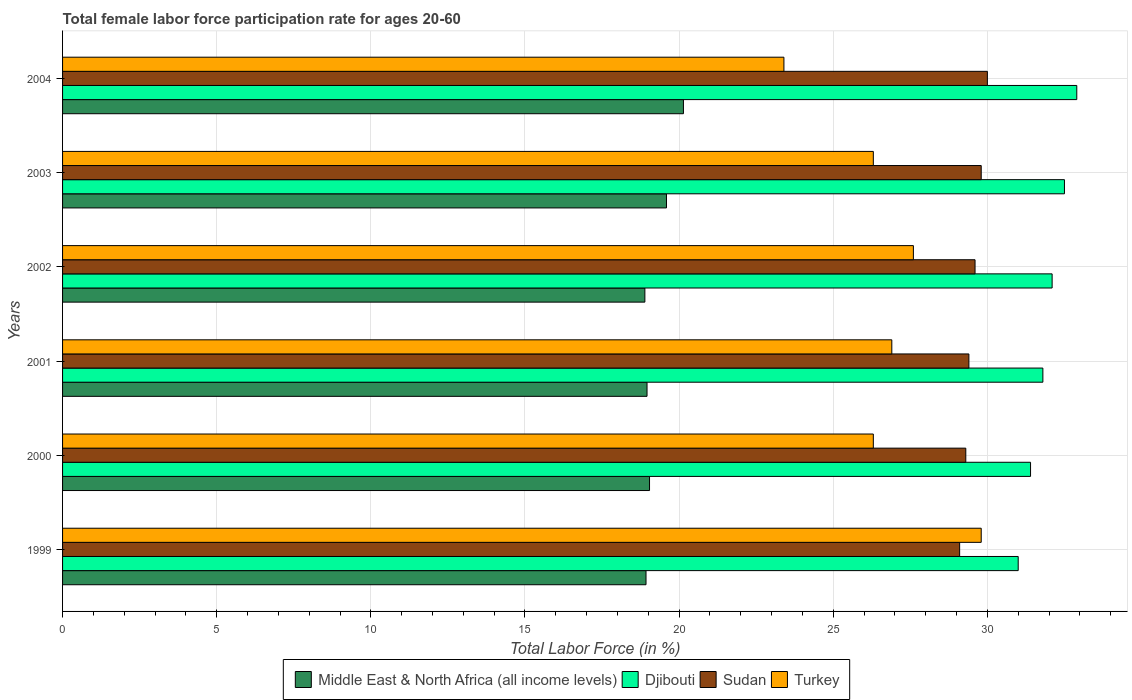How many groups of bars are there?
Offer a terse response. 6. Are the number of bars on each tick of the Y-axis equal?
Your answer should be very brief. Yes. How many bars are there on the 3rd tick from the bottom?
Provide a succinct answer. 4. What is the label of the 2nd group of bars from the top?
Provide a succinct answer. 2003. What is the female labor force participation rate in Turkey in 2001?
Give a very brief answer. 26.9. Across all years, what is the maximum female labor force participation rate in Middle East & North Africa (all income levels)?
Give a very brief answer. 20.14. Across all years, what is the minimum female labor force participation rate in Sudan?
Your response must be concise. 29.1. What is the total female labor force participation rate in Sudan in the graph?
Keep it short and to the point. 177.2. What is the difference between the female labor force participation rate in Djibouti in 2000 and that in 2002?
Provide a short and direct response. -0.7. What is the difference between the female labor force participation rate in Djibouti in 2001 and the female labor force participation rate in Sudan in 2003?
Offer a terse response. 2. What is the average female labor force participation rate in Middle East & North Africa (all income levels) per year?
Provide a succinct answer. 19.26. In the year 2003, what is the difference between the female labor force participation rate in Middle East & North Africa (all income levels) and female labor force participation rate in Sudan?
Keep it short and to the point. -10.21. What is the ratio of the female labor force participation rate in Sudan in 2001 to that in 2004?
Your answer should be very brief. 0.98. Is the female labor force participation rate in Djibouti in 2001 less than that in 2002?
Your answer should be compact. Yes. What is the difference between the highest and the second highest female labor force participation rate in Turkey?
Make the answer very short. 2.2. What is the difference between the highest and the lowest female labor force participation rate in Turkey?
Provide a succinct answer. 6.4. Is it the case that in every year, the sum of the female labor force participation rate in Djibouti and female labor force participation rate in Middle East & North Africa (all income levels) is greater than the sum of female labor force participation rate in Sudan and female labor force participation rate in Turkey?
Give a very brief answer. No. What does the 3rd bar from the top in 1999 represents?
Provide a short and direct response. Djibouti. Is it the case that in every year, the sum of the female labor force participation rate in Middle East & North Africa (all income levels) and female labor force participation rate in Turkey is greater than the female labor force participation rate in Djibouti?
Offer a terse response. Yes. How many bars are there?
Keep it short and to the point. 24. How many years are there in the graph?
Provide a short and direct response. 6. Does the graph contain grids?
Give a very brief answer. Yes. How many legend labels are there?
Keep it short and to the point. 4. How are the legend labels stacked?
Offer a terse response. Horizontal. What is the title of the graph?
Offer a very short reply. Total female labor force participation rate for ages 20-60. What is the Total Labor Force (in %) of Middle East & North Africa (all income levels) in 1999?
Your answer should be compact. 18.93. What is the Total Labor Force (in %) of Djibouti in 1999?
Offer a terse response. 31. What is the Total Labor Force (in %) of Sudan in 1999?
Your answer should be very brief. 29.1. What is the Total Labor Force (in %) of Turkey in 1999?
Your answer should be compact. 29.8. What is the Total Labor Force (in %) in Middle East & North Africa (all income levels) in 2000?
Provide a short and direct response. 19.04. What is the Total Labor Force (in %) of Djibouti in 2000?
Provide a succinct answer. 31.4. What is the Total Labor Force (in %) in Sudan in 2000?
Make the answer very short. 29.3. What is the Total Labor Force (in %) in Turkey in 2000?
Provide a short and direct response. 26.3. What is the Total Labor Force (in %) in Middle East & North Africa (all income levels) in 2001?
Your answer should be very brief. 18.96. What is the Total Labor Force (in %) in Djibouti in 2001?
Make the answer very short. 31.8. What is the Total Labor Force (in %) in Sudan in 2001?
Ensure brevity in your answer.  29.4. What is the Total Labor Force (in %) in Turkey in 2001?
Give a very brief answer. 26.9. What is the Total Labor Force (in %) of Middle East & North Africa (all income levels) in 2002?
Provide a succinct answer. 18.89. What is the Total Labor Force (in %) in Djibouti in 2002?
Provide a succinct answer. 32.1. What is the Total Labor Force (in %) in Sudan in 2002?
Keep it short and to the point. 29.6. What is the Total Labor Force (in %) of Turkey in 2002?
Keep it short and to the point. 27.6. What is the Total Labor Force (in %) of Middle East & North Africa (all income levels) in 2003?
Ensure brevity in your answer.  19.59. What is the Total Labor Force (in %) of Djibouti in 2003?
Keep it short and to the point. 32.5. What is the Total Labor Force (in %) of Sudan in 2003?
Make the answer very short. 29.8. What is the Total Labor Force (in %) of Turkey in 2003?
Make the answer very short. 26.3. What is the Total Labor Force (in %) of Middle East & North Africa (all income levels) in 2004?
Provide a short and direct response. 20.14. What is the Total Labor Force (in %) of Djibouti in 2004?
Provide a short and direct response. 32.9. What is the Total Labor Force (in %) in Turkey in 2004?
Offer a terse response. 23.4. Across all years, what is the maximum Total Labor Force (in %) of Middle East & North Africa (all income levels)?
Your answer should be very brief. 20.14. Across all years, what is the maximum Total Labor Force (in %) in Djibouti?
Your answer should be compact. 32.9. Across all years, what is the maximum Total Labor Force (in %) of Sudan?
Your answer should be compact. 30. Across all years, what is the maximum Total Labor Force (in %) of Turkey?
Provide a short and direct response. 29.8. Across all years, what is the minimum Total Labor Force (in %) of Middle East & North Africa (all income levels)?
Offer a very short reply. 18.89. Across all years, what is the minimum Total Labor Force (in %) of Djibouti?
Keep it short and to the point. 31. Across all years, what is the minimum Total Labor Force (in %) in Sudan?
Provide a short and direct response. 29.1. Across all years, what is the minimum Total Labor Force (in %) in Turkey?
Provide a short and direct response. 23.4. What is the total Total Labor Force (in %) of Middle East & North Africa (all income levels) in the graph?
Provide a short and direct response. 115.55. What is the total Total Labor Force (in %) in Djibouti in the graph?
Your answer should be very brief. 191.7. What is the total Total Labor Force (in %) of Sudan in the graph?
Ensure brevity in your answer.  177.2. What is the total Total Labor Force (in %) of Turkey in the graph?
Your answer should be very brief. 160.3. What is the difference between the Total Labor Force (in %) in Middle East & North Africa (all income levels) in 1999 and that in 2000?
Offer a very short reply. -0.11. What is the difference between the Total Labor Force (in %) of Djibouti in 1999 and that in 2000?
Keep it short and to the point. -0.4. What is the difference between the Total Labor Force (in %) in Middle East & North Africa (all income levels) in 1999 and that in 2001?
Make the answer very short. -0.03. What is the difference between the Total Labor Force (in %) of Turkey in 1999 and that in 2001?
Keep it short and to the point. 2.9. What is the difference between the Total Labor Force (in %) in Middle East & North Africa (all income levels) in 1999 and that in 2002?
Keep it short and to the point. 0.04. What is the difference between the Total Labor Force (in %) in Djibouti in 1999 and that in 2002?
Offer a very short reply. -1.1. What is the difference between the Total Labor Force (in %) in Middle East & North Africa (all income levels) in 1999 and that in 2003?
Ensure brevity in your answer.  -0.66. What is the difference between the Total Labor Force (in %) in Djibouti in 1999 and that in 2003?
Offer a terse response. -1.5. What is the difference between the Total Labor Force (in %) of Turkey in 1999 and that in 2003?
Your answer should be compact. 3.5. What is the difference between the Total Labor Force (in %) in Middle East & North Africa (all income levels) in 1999 and that in 2004?
Ensure brevity in your answer.  -1.21. What is the difference between the Total Labor Force (in %) in Djibouti in 1999 and that in 2004?
Offer a terse response. -1.9. What is the difference between the Total Labor Force (in %) of Turkey in 1999 and that in 2004?
Provide a short and direct response. 6.4. What is the difference between the Total Labor Force (in %) in Middle East & North Africa (all income levels) in 2000 and that in 2001?
Give a very brief answer. 0.08. What is the difference between the Total Labor Force (in %) of Turkey in 2000 and that in 2001?
Your response must be concise. -0.6. What is the difference between the Total Labor Force (in %) of Middle East & North Africa (all income levels) in 2000 and that in 2002?
Provide a succinct answer. 0.15. What is the difference between the Total Labor Force (in %) of Djibouti in 2000 and that in 2002?
Offer a terse response. -0.7. What is the difference between the Total Labor Force (in %) of Sudan in 2000 and that in 2002?
Give a very brief answer. -0.3. What is the difference between the Total Labor Force (in %) of Turkey in 2000 and that in 2002?
Make the answer very short. -1.3. What is the difference between the Total Labor Force (in %) of Middle East & North Africa (all income levels) in 2000 and that in 2003?
Provide a short and direct response. -0.55. What is the difference between the Total Labor Force (in %) in Djibouti in 2000 and that in 2003?
Ensure brevity in your answer.  -1.1. What is the difference between the Total Labor Force (in %) of Sudan in 2000 and that in 2003?
Provide a succinct answer. -0.5. What is the difference between the Total Labor Force (in %) of Turkey in 2000 and that in 2003?
Give a very brief answer. 0. What is the difference between the Total Labor Force (in %) in Middle East & North Africa (all income levels) in 2000 and that in 2004?
Your answer should be very brief. -1.1. What is the difference between the Total Labor Force (in %) in Middle East & North Africa (all income levels) in 2001 and that in 2002?
Ensure brevity in your answer.  0.07. What is the difference between the Total Labor Force (in %) in Djibouti in 2001 and that in 2002?
Make the answer very short. -0.3. What is the difference between the Total Labor Force (in %) in Middle East & North Africa (all income levels) in 2001 and that in 2003?
Offer a terse response. -0.63. What is the difference between the Total Labor Force (in %) in Turkey in 2001 and that in 2003?
Make the answer very short. 0.6. What is the difference between the Total Labor Force (in %) in Middle East & North Africa (all income levels) in 2001 and that in 2004?
Make the answer very short. -1.18. What is the difference between the Total Labor Force (in %) in Djibouti in 2001 and that in 2004?
Provide a short and direct response. -1.1. What is the difference between the Total Labor Force (in %) of Sudan in 2001 and that in 2004?
Your answer should be very brief. -0.6. What is the difference between the Total Labor Force (in %) of Turkey in 2001 and that in 2004?
Offer a terse response. 3.5. What is the difference between the Total Labor Force (in %) in Middle East & North Africa (all income levels) in 2002 and that in 2003?
Provide a short and direct response. -0.7. What is the difference between the Total Labor Force (in %) in Sudan in 2002 and that in 2003?
Your response must be concise. -0.2. What is the difference between the Total Labor Force (in %) of Turkey in 2002 and that in 2003?
Provide a short and direct response. 1.3. What is the difference between the Total Labor Force (in %) in Middle East & North Africa (all income levels) in 2002 and that in 2004?
Offer a very short reply. -1.25. What is the difference between the Total Labor Force (in %) in Middle East & North Africa (all income levels) in 2003 and that in 2004?
Your response must be concise. -0.55. What is the difference between the Total Labor Force (in %) in Djibouti in 2003 and that in 2004?
Give a very brief answer. -0.4. What is the difference between the Total Labor Force (in %) in Sudan in 2003 and that in 2004?
Provide a short and direct response. -0.2. What is the difference between the Total Labor Force (in %) in Turkey in 2003 and that in 2004?
Offer a terse response. 2.9. What is the difference between the Total Labor Force (in %) in Middle East & North Africa (all income levels) in 1999 and the Total Labor Force (in %) in Djibouti in 2000?
Offer a very short reply. -12.47. What is the difference between the Total Labor Force (in %) of Middle East & North Africa (all income levels) in 1999 and the Total Labor Force (in %) of Sudan in 2000?
Your response must be concise. -10.37. What is the difference between the Total Labor Force (in %) in Middle East & North Africa (all income levels) in 1999 and the Total Labor Force (in %) in Turkey in 2000?
Your answer should be very brief. -7.37. What is the difference between the Total Labor Force (in %) in Djibouti in 1999 and the Total Labor Force (in %) in Turkey in 2000?
Your response must be concise. 4.7. What is the difference between the Total Labor Force (in %) of Sudan in 1999 and the Total Labor Force (in %) of Turkey in 2000?
Keep it short and to the point. 2.8. What is the difference between the Total Labor Force (in %) in Middle East & North Africa (all income levels) in 1999 and the Total Labor Force (in %) in Djibouti in 2001?
Ensure brevity in your answer.  -12.87. What is the difference between the Total Labor Force (in %) in Middle East & North Africa (all income levels) in 1999 and the Total Labor Force (in %) in Sudan in 2001?
Provide a short and direct response. -10.47. What is the difference between the Total Labor Force (in %) in Middle East & North Africa (all income levels) in 1999 and the Total Labor Force (in %) in Turkey in 2001?
Make the answer very short. -7.97. What is the difference between the Total Labor Force (in %) in Djibouti in 1999 and the Total Labor Force (in %) in Sudan in 2001?
Your answer should be compact. 1.6. What is the difference between the Total Labor Force (in %) in Djibouti in 1999 and the Total Labor Force (in %) in Turkey in 2001?
Offer a terse response. 4.1. What is the difference between the Total Labor Force (in %) in Sudan in 1999 and the Total Labor Force (in %) in Turkey in 2001?
Offer a very short reply. 2.2. What is the difference between the Total Labor Force (in %) in Middle East & North Africa (all income levels) in 1999 and the Total Labor Force (in %) in Djibouti in 2002?
Keep it short and to the point. -13.17. What is the difference between the Total Labor Force (in %) of Middle East & North Africa (all income levels) in 1999 and the Total Labor Force (in %) of Sudan in 2002?
Provide a short and direct response. -10.67. What is the difference between the Total Labor Force (in %) of Middle East & North Africa (all income levels) in 1999 and the Total Labor Force (in %) of Turkey in 2002?
Make the answer very short. -8.67. What is the difference between the Total Labor Force (in %) of Djibouti in 1999 and the Total Labor Force (in %) of Sudan in 2002?
Keep it short and to the point. 1.4. What is the difference between the Total Labor Force (in %) of Djibouti in 1999 and the Total Labor Force (in %) of Turkey in 2002?
Provide a succinct answer. 3.4. What is the difference between the Total Labor Force (in %) of Middle East & North Africa (all income levels) in 1999 and the Total Labor Force (in %) of Djibouti in 2003?
Offer a very short reply. -13.57. What is the difference between the Total Labor Force (in %) in Middle East & North Africa (all income levels) in 1999 and the Total Labor Force (in %) in Sudan in 2003?
Provide a short and direct response. -10.87. What is the difference between the Total Labor Force (in %) of Middle East & North Africa (all income levels) in 1999 and the Total Labor Force (in %) of Turkey in 2003?
Give a very brief answer. -7.37. What is the difference between the Total Labor Force (in %) of Djibouti in 1999 and the Total Labor Force (in %) of Turkey in 2003?
Provide a succinct answer. 4.7. What is the difference between the Total Labor Force (in %) in Sudan in 1999 and the Total Labor Force (in %) in Turkey in 2003?
Ensure brevity in your answer.  2.8. What is the difference between the Total Labor Force (in %) of Middle East & North Africa (all income levels) in 1999 and the Total Labor Force (in %) of Djibouti in 2004?
Offer a terse response. -13.97. What is the difference between the Total Labor Force (in %) of Middle East & North Africa (all income levels) in 1999 and the Total Labor Force (in %) of Sudan in 2004?
Make the answer very short. -11.07. What is the difference between the Total Labor Force (in %) of Middle East & North Africa (all income levels) in 1999 and the Total Labor Force (in %) of Turkey in 2004?
Provide a succinct answer. -4.47. What is the difference between the Total Labor Force (in %) in Djibouti in 1999 and the Total Labor Force (in %) in Turkey in 2004?
Provide a short and direct response. 7.6. What is the difference between the Total Labor Force (in %) of Middle East & North Africa (all income levels) in 2000 and the Total Labor Force (in %) of Djibouti in 2001?
Your answer should be compact. -12.76. What is the difference between the Total Labor Force (in %) in Middle East & North Africa (all income levels) in 2000 and the Total Labor Force (in %) in Sudan in 2001?
Provide a short and direct response. -10.36. What is the difference between the Total Labor Force (in %) in Middle East & North Africa (all income levels) in 2000 and the Total Labor Force (in %) in Turkey in 2001?
Ensure brevity in your answer.  -7.86. What is the difference between the Total Labor Force (in %) of Djibouti in 2000 and the Total Labor Force (in %) of Sudan in 2001?
Keep it short and to the point. 2. What is the difference between the Total Labor Force (in %) of Middle East & North Africa (all income levels) in 2000 and the Total Labor Force (in %) of Djibouti in 2002?
Provide a short and direct response. -13.06. What is the difference between the Total Labor Force (in %) of Middle East & North Africa (all income levels) in 2000 and the Total Labor Force (in %) of Sudan in 2002?
Offer a very short reply. -10.56. What is the difference between the Total Labor Force (in %) of Middle East & North Africa (all income levels) in 2000 and the Total Labor Force (in %) of Turkey in 2002?
Provide a succinct answer. -8.56. What is the difference between the Total Labor Force (in %) of Djibouti in 2000 and the Total Labor Force (in %) of Turkey in 2002?
Your answer should be compact. 3.8. What is the difference between the Total Labor Force (in %) in Sudan in 2000 and the Total Labor Force (in %) in Turkey in 2002?
Provide a short and direct response. 1.7. What is the difference between the Total Labor Force (in %) in Middle East & North Africa (all income levels) in 2000 and the Total Labor Force (in %) in Djibouti in 2003?
Give a very brief answer. -13.46. What is the difference between the Total Labor Force (in %) of Middle East & North Africa (all income levels) in 2000 and the Total Labor Force (in %) of Sudan in 2003?
Provide a short and direct response. -10.76. What is the difference between the Total Labor Force (in %) of Middle East & North Africa (all income levels) in 2000 and the Total Labor Force (in %) of Turkey in 2003?
Your answer should be very brief. -7.26. What is the difference between the Total Labor Force (in %) of Djibouti in 2000 and the Total Labor Force (in %) of Sudan in 2003?
Your answer should be compact. 1.6. What is the difference between the Total Labor Force (in %) in Djibouti in 2000 and the Total Labor Force (in %) in Turkey in 2003?
Provide a short and direct response. 5.1. What is the difference between the Total Labor Force (in %) in Middle East & North Africa (all income levels) in 2000 and the Total Labor Force (in %) in Djibouti in 2004?
Keep it short and to the point. -13.86. What is the difference between the Total Labor Force (in %) of Middle East & North Africa (all income levels) in 2000 and the Total Labor Force (in %) of Sudan in 2004?
Offer a terse response. -10.96. What is the difference between the Total Labor Force (in %) in Middle East & North Africa (all income levels) in 2000 and the Total Labor Force (in %) in Turkey in 2004?
Provide a succinct answer. -4.36. What is the difference between the Total Labor Force (in %) of Djibouti in 2000 and the Total Labor Force (in %) of Sudan in 2004?
Give a very brief answer. 1.4. What is the difference between the Total Labor Force (in %) of Djibouti in 2000 and the Total Labor Force (in %) of Turkey in 2004?
Ensure brevity in your answer.  8. What is the difference between the Total Labor Force (in %) in Middle East & North Africa (all income levels) in 2001 and the Total Labor Force (in %) in Djibouti in 2002?
Provide a short and direct response. -13.14. What is the difference between the Total Labor Force (in %) of Middle East & North Africa (all income levels) in 2001 and the Total Labor Force (in %) of Sudan in 2002?
Your answer should be compact. -10.64. What is the difference between the Total Labor Force (in %) of Middle East & North Africa (all income levels) in 2001 and the Total Labor Force (in %) of Turkey in 2002?
Ensure brevity in your answer.  -8.64. What is the difference between the Total Labor Force (in %) of Middle East & North Africa (all income levels) in 2001 and the Total Labor Force (in %) of Djibouti in 2003?
Offer a very short reply. -13.54. What is the difference between the Total Labor Force (in %) in Middle East & North Africa (all income levels) in 2001 and the Total Labor Force (in %) in Sudan in 2003?
Offer a very short reply. -10.84. What is the difference between the Total Labor Force (in %) of Middle East & North Africa (all income levels) in 2001 and the Total Labor Force (in %) of Turkey in 2003?
Offer a terse response. -7.34. What is the difference between the Total Labor Force (in %) in Djibouti in 2001 and the Total Labor Force (in %) in Sudan in 2003?
Provide a short and direct response. 2. What is the difference between the Total Labor Force (in %) of Djibouti in 2001 and the Total Labor Force (in %) of Turkey in 2003?
Provide a succinct answer. 5.5. What is the difference between the Total Labor Force (in %) in Sudan in 2001 and the Total Labor Force (in %) in Turkey in 2003?
Offer a very short reply. 3.1. What is the difference between the Total Labor Force (in %) in Middle East & North Africa (all income levels) in 2001 and the Total Labor Force (in %) in Djibouti in 2004?
Your response must be concise. -13.94. What is the difference between the Total Labor Force (in %) in Middle East & North Africa (all income levels) in 2001 and the Total Labor Force (in %) in Sudan in 2004?
Offer a very short reply. -11.04. What is the difference between the Total Labor Force (in %) in Middle East & North Africa (all income levels) in 2001 and the Total Labor Force (in %) in Turkey in 2004?
Ensure brevity in your answer.  -4.44. What is the difference between the Total Labor Force (in %) of Djibouti in 2001 and the Total Labor Force (in %) of Sudan in 2004?
Ensure brevity in your answer.  1.8. What is the difference between the Total Labor Force (in %) in Djibouti in 2001 and the Total Labor Force (in %) in Turkey in 2004?
Offer a terse response. 8.4. What is the difference between the Total Labor Force (in %) of Middle East & North Africa (all income levels) in 2002 and the Total Labor Force (in %) of Djibouti in 2003?
Make the answer very short. -13.61. What is the difference between the Total Labor Force (in %) of Middle East & North Africa (all income levels) in 2002 and the Total Labor Force (in %) of Sudan in 2003?
Your response must be concise. -10.91. What is the difference between the Total Labor Force (in %) of Middle East & North Africa (all income levels) in 2002 and the Total Labor Force (in %) of Turkey in 2003?
Offer a terse response. -7.41. What is the difference between the Total Labor Force (in %) of Middle East & North Africa (all income levels) in 2002 and the Total Labor Force (in %) of Djibouti in 2004?
Keep it short and to the point. -14.01. What is the difference between the Total Labor Force (in %) in Middle East & North Africa (all income levels) in 2002 and the Total Labor Force (in %) in Sudan in 2004?
Your answer should be very brief. -11.11. What is the difference between the Total Labor Force (in %) in Middle East & North Africa (all income levels) in 2002 and the Total Labor Force (in %) in Turkey in 2004?
Ensure brevity in your answer.  -4.51. What is the difference between the Total Labor Force (in %) in Djibouti in 2002 and the Total Labor Force (in %) in Sudan in 2004?
Your answer should be compact. 2.1. What is the difference between the Total Labor Force (in %) of Middle East & North Africa (all income levels) in 2003 and the Total Labor Force (in %) of Djibouti in 2004?
Ensure brevity in your answer.  -13.31. What is the difference between the Total Labor Force (in %) of Middle East & North Africa (all income levels) in 2003 and the Total Labor Force (in %) of Sudan in 2004?
Your answer should be very brief. -10.41. What is the difference between the Total Labor Force (in %) of Middle East & North Africa (all income levels) in 2003 and the Total Labor Force (in %) of Turkey in 2004?
Your response must be concise. -3.81. What is the difference between the Total Labor Force (in %) in Djibouti in 2003 and the Total Labor Force (in %) in Sudan in 2004?
Provide a succinct answer. 2.5. What is the difference between the Total Labor Force (in %) of Djibouti in 2003 and the Total Labor Force (in %) of Turkey in 2004?
Your response must be concise. 9.1. What is the average Total Labor Force (in %) of Middle East & North Africa (all income levels) per year?
Provide a succinct answer. 19.26. What is the average Total Labor Force (in %) of Djibouti per year?
Offer a terse response. 31.95. What is the average Total Labor Force (in %) of Sudan per year?
Offer a very short reply. 29.53. What is the average Total Labor Force (in %) in Turkey per year?
Your answer should be very brief. 26.72. In the year 1999, what is the difference between the Total Labor Force (in %) of Middle East & North Africa (all income levels) and Total Labor Force (in %) of Djibouti?
Keep it short and to the point. -12.07. In the year 1999, what is the difference between the Total Labor Force (in %) in Middle East & North Africa (all income levels) and Total Labor Force (in %) in Sudan?
Your response must be concise. -10.17. In the year 1999, what is the difference between the Total Labor Force (in %) in Middle East & North Africa (all income levels) and Total Labor Force (in %) in Turkey?
Ensure brevity in your answer.  -10.87. In the year 1999, what is the difference between the Total Labor Force (in %) in Djibouti and Total Labor Force (in %) in Turkey?
Your answer should be compact. 1.2. In the year 2000, what is the difference between the Total Labor Force (in %) in Middle East & North Africa (all income levels) and Total Labor Force (in %) in Djibouti?
Make the answer very short. -12.36. In the year 2000, what is the difference between the Total Labor Force (in %) of Middle East & North Africa (all income levels) and Total Labor Force (in %) of Sudan?
Offer a very short reply. -10.26. In the year 2000, what is the difference between the Total Labor Force (in %) of Middle East & North Africa (all income levels) and Total Labor Force (in %) of Turkey?
Offer a terse response. -7.26. In the year 2000, what is the difference between the Total Labor Force (in %) in Djibouti and Total Labor Force (in %) in Turkey?
Keep it short and to the point. 5.1. In the year 2001, what is the difference between the Total Labor Force (in %) of Middle East & North Africa (all income levels) and Total Labor Force (in %) of Djibouti?
Your response must be concise. -12.84. In the year 2001, what is the difference between the Total Labor Force (in %) in Middle East & North Africa (all income levels) and Total Labor Force (in %) in Sudan?
Offer a terse response. -10.44. In the year 2001, what is the difference between the Total Labor Force (in %) of Middle East & North Africa (all income levels) and Total Labor Force (in %) of Turkey?
Give a very brief answer. -7.94. In the year 2001, what is the difference between the Total Labor Force (in %) of Djibouti and Total Labor Force (in %) of Sudan?
Make the answer very short. 2.4. In the year 2002, what is the difference between the Total Labor Force (in %) in Middle East & North Africa (all income levels) and Total Labor Force (in %) in Djibouti?
Your response must be concise. -13.21. In the year 2002, what is the difference between the Total Labor Force (in %) of Middle East & North Africa (all income levels) and Total Labor Force (in %) of Sudan?
Your answer should be compact. -10.71. In the year 2002, what is the difference between the Total Labor Force (in %) in Middle East & North Africa (all income levels) and Total Labor Force (in %) in Turkey?
Provide a succinct answer. -8.71. In the year 2002, what is the difference between the Total Labor Force (in %) in Djibouti and Total Labor Force (in %) in Turkey?
Your response must be concise. 4.5. In the year 2003, what is the difference between the Total Labor Force (in %) of Middle East & North Africa (all income levels) and Total Labor Force (in %) of Djibouti?
Your answer should be compact. -12.91. In the year 2003, what is the difference between the Total Labor Force (in %) of Middle East & North Africa (all income levels) and Total Labor Force (in %) of Sudan?
Your answer should be compact. -10.21. In the year 2003, what is the difference between the Total Labor Force (in %) in Middle East & North Africa (all income levels) and Total Labor Force (in %) in Turkey?
Offer a terse response. -6.71. In the year 2003, what is the difference between the Total Labor Force (in %) in Sudan and Total Labor Force (in %) in Turkey?
Keep it short and to the point. 3.5. In the year 2004, what is the difference between the Total Labor Force (in %) in Middle East & North Africa (all income levels) and Total Labor Force (in %) in Djibouti?
Provide a short and direct response. -12.76. In the year 2004, what is the difference between the Total Labor Force (in %) of Middle East & North Africa (all income levels) and Total Labor Force (in %) of Sudan?
Your answer should be compact. -9.86. In the year 2004, what is the difference between the Total Labor Force (in %) of Middle East & North Africa (all income levels) and Total Labor Force (in %) of Turkey?
Give a very brief answer. -3.26. In the year 2004, what is the difference between the Total Labor Force (in %) of Djibouti and Total Labor Force (in %) of Sudan?
Ensure brevity in your answer.  2.9. In the year 2004, what is the difference between the Total Labor Force (in %) of Djibouti and Total Labor Force (in %) of Turkey?
Offer a terse response. 9.5. In the year 2004, what is the difference between the Total Labor Force (in %) of Sudan and Total Labor Force (in %) of Turkey?
Make the answer very short. 6.6. What is the ratio of the Total Labor Force (in %) of Djibouti in 1999 to that in 2000?
Provide a short and direct response. 0.99. What is the ratio of the Total Labor Force (in %) of Sudan in 1999 to that in 2000?
Give a very brief answer. 0.99. What is the ratio of the Total Labor Force (in %) of Turkey in 1999 to that in 2000?
Offer a very short reply. 1.13. What is the ratio of the Total Labor Force (in %) in Djibouti in 1999 to that in 2001?
Ensure brevity in your answer.  0.97. What is the ratio of the Total Labor Force (in %) in Sudan in 1999 to that in 2001?
Your answer should be compact. 0.99. What is the ratio of the Total Labor Force (in %) in Turkey in 1999 to that in 2001?
Your answer should be compact. 1.11. What is the ratio of the Total Labor Force (in %) in Djibouti in 1999 to that in 2002?
Offer a terse response. 0.97. What is the ratio of the Total Labor Force (in %) in Sudan in 1999 to that in 2002?
Your answer should be compact. 0.98. What is the ratio of the Total Labor Force (in %) of Turkey in 1999 to that in 2002?
Keep it short and to the point. 1.08. What is the ratio of the Total Labor Force (in %) in Middle East & North Africa (all income levels) in 1999 to that in 2003?
Provide a succinct answer. 0.97. What is the ratio of the Total Labor Force (in %) of Djibouti in 1999 to that in 2003?
Keep it short and to the point. 0.95. What is the ratio of the Total Labor Force (in %) of Sudan in 1999 to that in 2003?
Keep it short and to the point. 0.98. What is the ratio of the Total Labor Force (in %) of Turkey in 1999 to that in 2003?
Keep it short and to the point. 1.13. What is the ratio of the Total Labor Force (in %) of Middle East & North Africa (all income levels) in 1999 to that in 2004?
Your response must be concise. 0.94. What is the ratio of the Total Labor Force (in %) of Djibouti in 1999 to that in 2004?
Your answer should be very brief. 0.94. What is the ratio of the Total Labor Force (in %) in Turkey in 1999 to that in 2004?
Your response must be concise. 1.27. What is the ratio of the Total Labor Force (in %) in Djibouti in 2000 to that in 2001?
Your answer should be very brief. 0.99. What is the ratio of the Total Labor Force (in %) of Turkey in 2000 to that in 2001?
Offer a very short reply. 0.98. What is the ratio of the Total Labor Force (in %) of Middle East & North Africa (all income levels) in 2000 to that in 2002?
Your answer should be compact. 1.01. What is the ratio of the Total Labor Force (in %) in Djibouti in 2000 to that in 2002?
Your answer should be compact. 0.98. What is the ratio of the Total Labor Force (in %) in Turkey in 2000 to that in 2002?
Offer a terse response. 0.95. What is the ratio of the Total Labor Force (in %) in Middle East & North Africa (all income levels) in 2000 to that in 2003?
Make the answer very short. 0.97. What is the ratio of the Total Labor Force (in %) of Djibouti in 2000 to that in 2003?
Provide a short and direct response. 0.97. What is the ratio of the Total Labor Force (in %) in Sudan in 2000 to that in 2003?
Offer a terse response. 0.98. What is the ratio of the Total Labor Force (in %) of Middle East & North Africa (all income levels) in 2000 to that in 2004?
Make the answer very short. 0.95. What is the ratio of the Total Labor Force (in %) in Djibouti in 2000 to that in 2004?
Keep it short and to the point. 0.95. What is the ratio of the Total Labor Force (in %) of Sudan in 2000 to that in 2004?
Ensure brevity in your answer.  0.98. What is the ratio of the Total Labor Force (in %) of Turkey in 2000 to that in 2004?
Your answer should be very brief. 1.12. What is the ratio of the Total Labor Force (in %) of Middle East & North Africa (all income levels) in 2001 to that in 2002?
Ensure brevity in your answer.  1. What is the ratio of the Total Labor Force (in %) in Turkey in 2001 to that in 2002?
Your response must be concise. 0.97. What is the ratio of the Total Labor Force (in %) in Middle East & North Africa (all income levels) in 2001 to that in 2003?
Give a very brief answer. 0.97. What is the ratio of the Total Labor Force (in %) of Djibouti in 2001 to that in 2003?
Offer a terse response. 0.98. What is the ratio of the Total Labor Force (in %) of Sudan in 2001 to that in 2003?
Your answer should be compact. 0.99. What is the ratio of the Total Labor Force (in %) in Turkey in 2001 to that in 2003?
Your answer should be very brief. 1.02. What is the ratio of the Total Labor Force (in %) in Middle East & North Africa (all income levels) in 2001 to that in 2004?
Keep it short and to the point. 0.94. What is the ratio of the Total Labor Force (in %) in Djibouti in 2001 to that in 2004?
Provide a succinct answer. 0.97. What is the ratio of the Total Labor Force (in %) of Sudan in 2001 to that in 2004?
Keep it short and to the point. 0.98. What is the ratio of the Total Labor Force (in %) of Turkey in 2001 to that in 2004?
Provide a short and direct response. 1.15. What is the ratio of the Total Labor Force (in %) in Middle East & North Africa (all income levels) in 2002 to that in 2003?
Keep it short and to the point. 0.96. What is the ratio of the Total Labor Force (in %) of Djibouti in 2002 to that in 2003?
Provide a succinct answer. 0.99. What is the ratio of the Total Labor Force (in %) of Turkey in 2002 to that in 2003?
Offer a very short reply. 1.05. What is the ratio of the Total Labor Force (in %) of Middle East & North Africa (all income levels) in 2002 to that in 2004?
Give a very brief answer. 0.94. What is the ratio of the Total Labor Force (in %) in Djibouti in 2002 to that in 2004?
Offer a very short reply. 0.98. What is the ratio of the Total Labor Force (in %) of Sudan in 2002 to that in 2004?
Offer a very short reply. 0.99. What is the ratio of the Total Labor Force (in %) in Turkey in 2002 to that in 2004?
Your answer should be very brief. 1.18. What is the ratio of the Total Labor Force (in %) in Middle East & North Africa (all income levels) in 2003 to that in 2004?
Your answer should be very brief. 0.97. What is the ratio of the Total Labor Force (in %) in Turkey in 2003 to that in 2004?
Offer a very short reply. 1.12. What is the difference between the highest and the second highest Total Labor Force (in %) of Middle East & North Africa (all income levels)?
Your answer should be very brief. 0.55. What is the difference between the highest and the second highest Total Labor Force (in %) in Djibouti?
Provide a succinct answer. 0.4. What is the difference between the highest and the second highest Total Labor Force (in %) of Sudan?
Offer a very short reply. 0.2. What is the difference between the highest and the second highest Total Labor Force (in %) of Turkey?
Provide a short and direct response. 2.2. What is the difference between the highest and the lowest Total Labor Force (in %) of Middle East & North Africa (all income levels)?
Your answer should be very brief. 1.25. What is the difference between the highest and the lowest Total Labor Force (in %) of Turkey?
Keep it short and to the point. 6.4. 